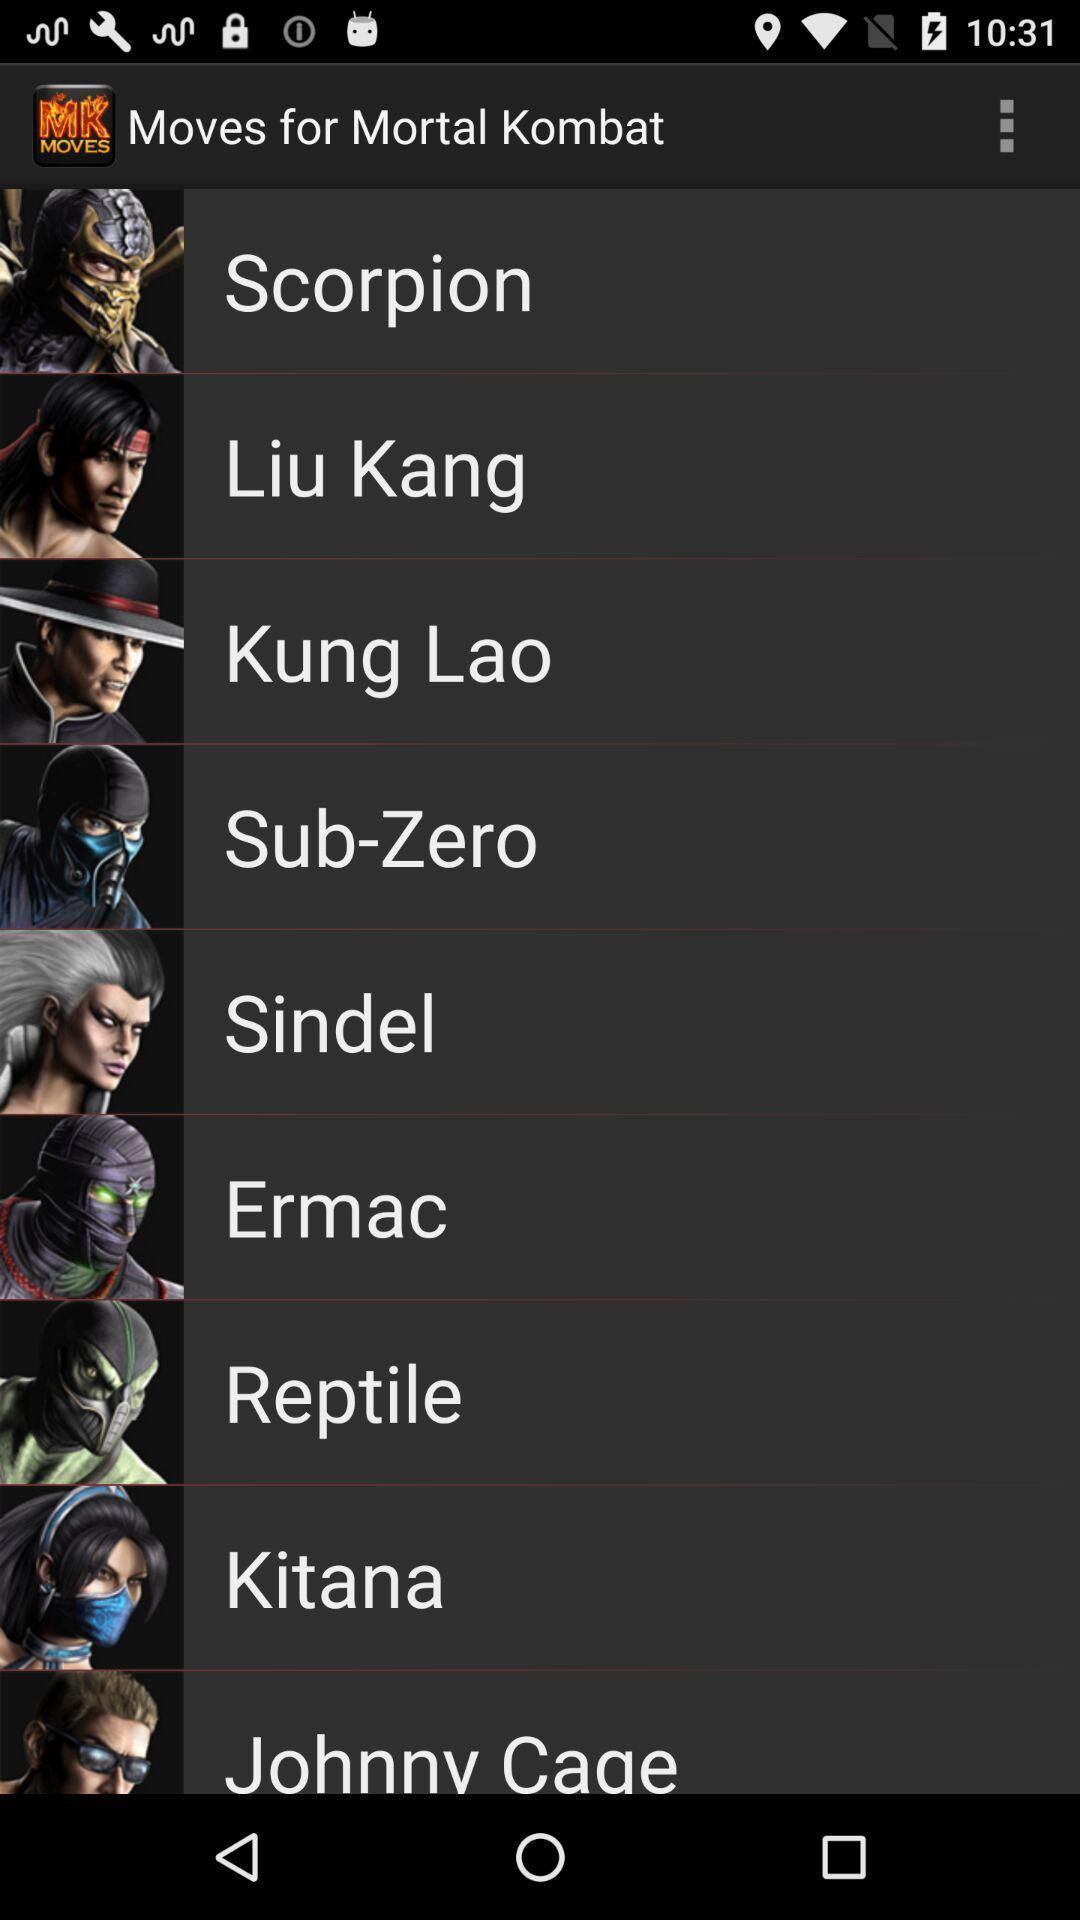Describe the visual elements of this screenshot. Page displaying with list of movies in application. 